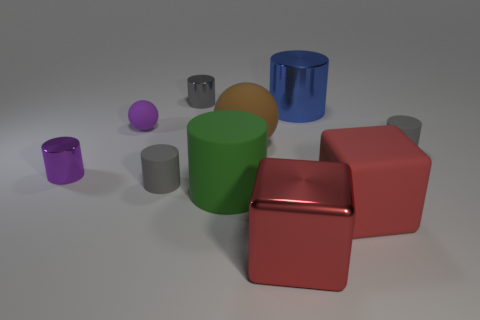Subtract all big rubber cylinders. How many cylinders are left? 5 Subtract all green cylinders. How many cylinders are left? 5 Subtract 2 blocks. How many blocks are left? 0 Subtract all gray metallic cylinders. Subtract all small gray cylinders. How many objects are left? 6 Add 2 gray metallic things. How many gray metallic things are left? 3 Add 1 tiny blue cylinders. How many tiny blue cylinders exist? 1 Subtract 0 cyan cylinders. How many objects are left? 10 Subtract all balls. How many objects are left? 8 Subtract all cyan spheres. Subtract all cyan cylinders. How many spheres are left? 2 Subtract all gray spheres. How many gray cylinders are left? 3 